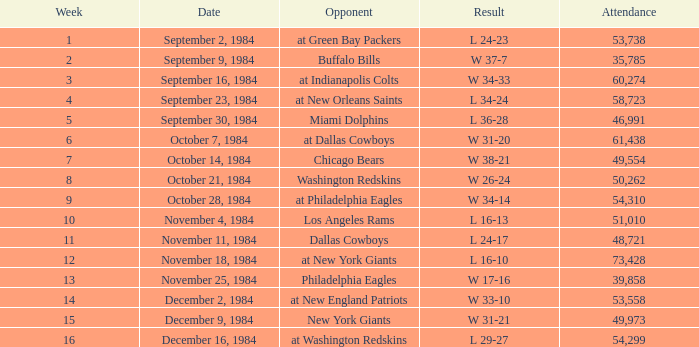What was the result in a week lower than 10 with an opponent of Chicago Bears? W 38-21. 